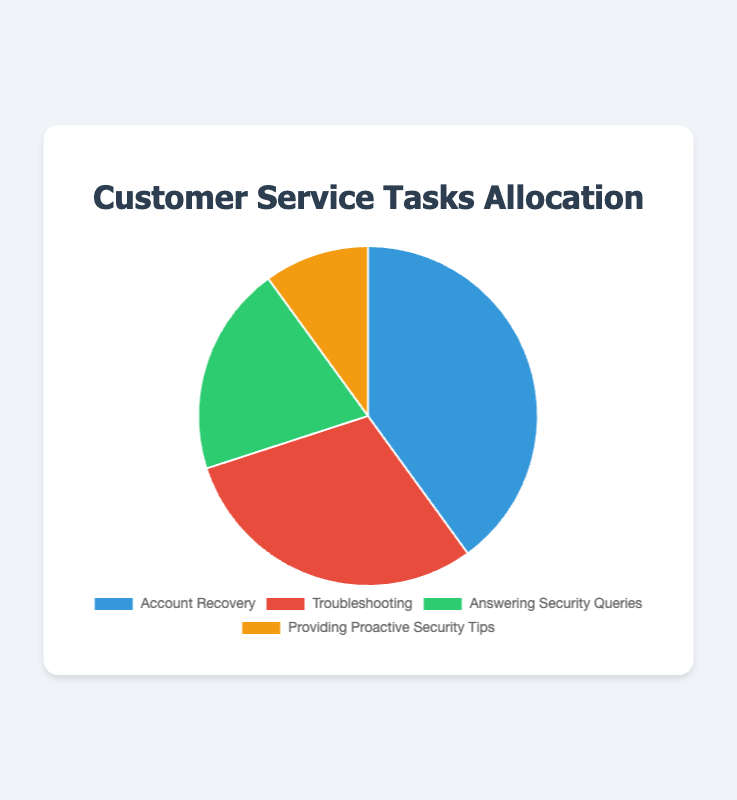Which customer service task takes up the largest percentage of time? The figure shows that "Account Recovery" takes up 40% of the total time, which is the largest percentage among the tasks listed.
Answer: Account Recovery How much more time is spent on Troubleshooting compared to Providing Proactive Security Tips? According to the figure, Troubleshooting accounts for 30% of the time, and Providing Proactive Security Tips accounts for 10%. The difference is 30% - 10% = 20%.
Answer: 20% Which task occupies the smallest percentage of time? The figure indicates that "Providing Proactive Security Tips" takes up 10%, which is the smallest percentage among all listed tasks.
Answer: Providing Proactive Security Tips What is the combined percentage of time spent on Answering Security Queries and Providing Proactive Security Tips? The figure shows that 20% of the time is spent on Answering Security Queries and 10% on Providing Proactive Security Tips. Adding these together gives 20% + 10% = 30%.
Answer: 30% Is more time spent on Account Recovery or on Troubleshooting and Answering Security Queries combined? The figure shows that Account Recovery takes 40% of the time. Troubleshooting and Answering Security Queries combined is 30% + 20% = 50%. Since 50% is greater than 40%, more time is spent on Troubleshooting and Answering Security Queries combined.
Answer: Troubleshooting and Answering Security Queries combined What colors represent Troubleshooting and Answering Security Queries in the pie chart? Troubleshooting is represented by the red section of the pie chart, and Answering Security Queries is represented by the green section.
Answer: Red and Green 